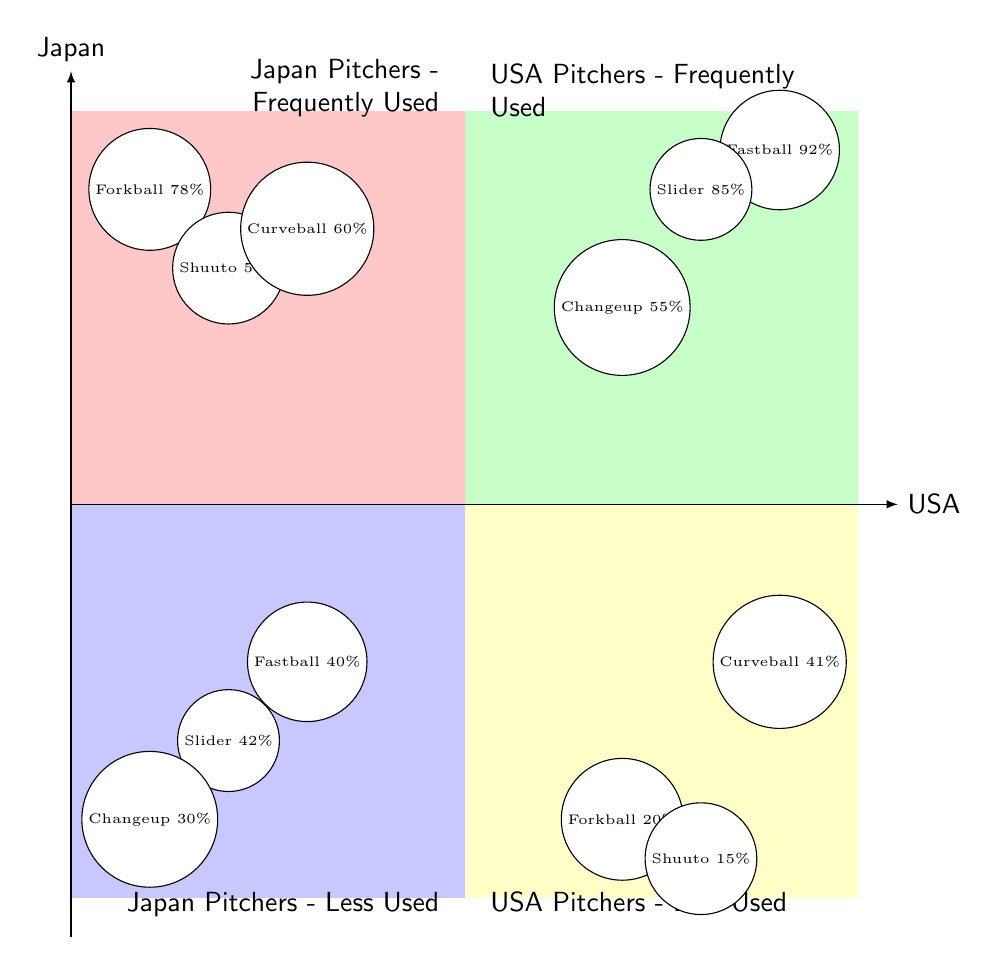What is the most popular pitch type for USA pitchers? The diagram indicates that the Fastball is the most frequently used pitch type among USA pitchers, with a popularity of 92%.
Answer: Fastball How many pitch types are frequently used by Japan pitchers? In the Q1 quadrant, there are three pitch types listed as frequently used by Japan pitchers: Forkball, Shuuto, and Curveball.
Answer: Three Which pitch type is the least popular among USA pitchers? In the Q4 quadrant, the Forkball is listed as having the lowest popularity at 20%.
Answer: Forkball Which pitch has higher popularity, Shuutos by Japan pitchers or Changeups by USA pitchers? The Shuuto has a popularity of 54% (Q1), while the Changeup has a popularity of 55% (Q2). Since 55% is higher than 54%, the Changeup is more popular.
Answer: Changeup What is the popularity percentage of the Curveball for Japan pitchers? The Curveball is noted in the Q1 quadrant with a popularity of 60%.
Answer: 60% How does the popularity of the Fastball for Japan pitchers compare to its popularity for USA pitchers? The Fastball has a popularity of 40% for Japan pitchers (Q3) and 92% for USA pitchers (Q2). This shows that the Fastball is substantially more popular among USA pitchers.
Answer: 92% (USA), 40% (Japan) Which quadrant represents the less frequently used pitch types for USA pitchers? The quadrant labeled Q4 contains the less frequently used pitches for USA pitchers.
Answer: Q4 What is the combined popularity percentage of all frequently used pitch types for Japan pitchers? The popularity of the Forkball (78%), Shuuto (54%), and Curveball (60%) needs to be added: 78 + 54 + 60 = 192%.
Answer: 192% 